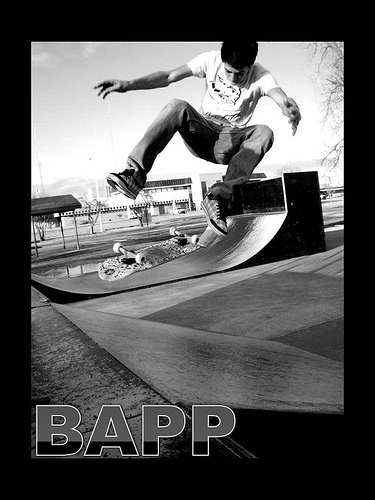Could you describe the setting and how it might influence the skateboarder's performance? The setting is a skate park with smooth ramps designed specifically for tricks like the one pictured. The tailored environment allows skateboarders to perform at their best, offering various surfaces and angles for creative and challenging maneuvers. What does the graffiti on the ramp add to the scene? The graffiti on the ramp gives the skate park character and reflects the urban, rebellious culture often associated with skateboarding. It also visually enhances the skate park, making it more appealing and personalized for those who use it. 